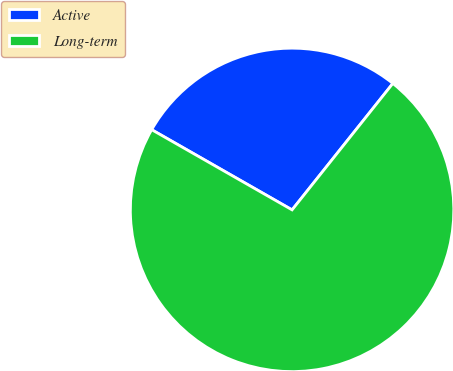Convert chart to OTSL. <chart><loc_0><loc_0><loc_500><loc_500><pie_chart><fcel>Active<fcel>Long-term<nl><fcel>27.45%<fcel>72.55%<nl></chart> 